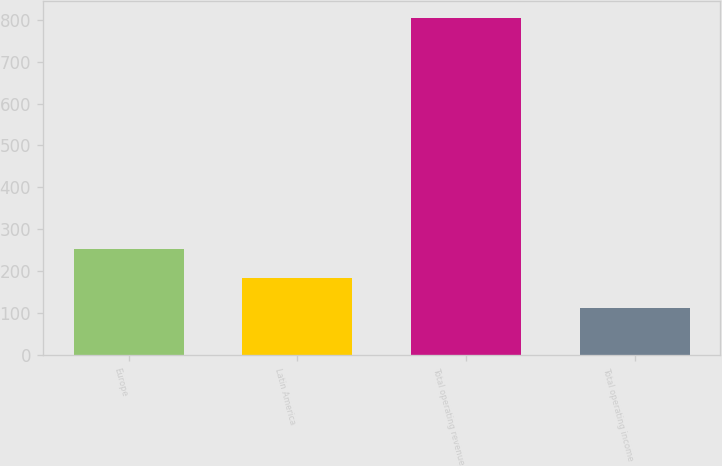<chart> <loc_0><loc_0><loc_500><loc_500><bar_chart><fcel>Europe<fcel>Latin America<fcel>Total operating revenue<fcel>Total operating income<nl><fcel>253.6<fcel>183.9<fcel>803.6<fcel>111.4<nl></chart> 